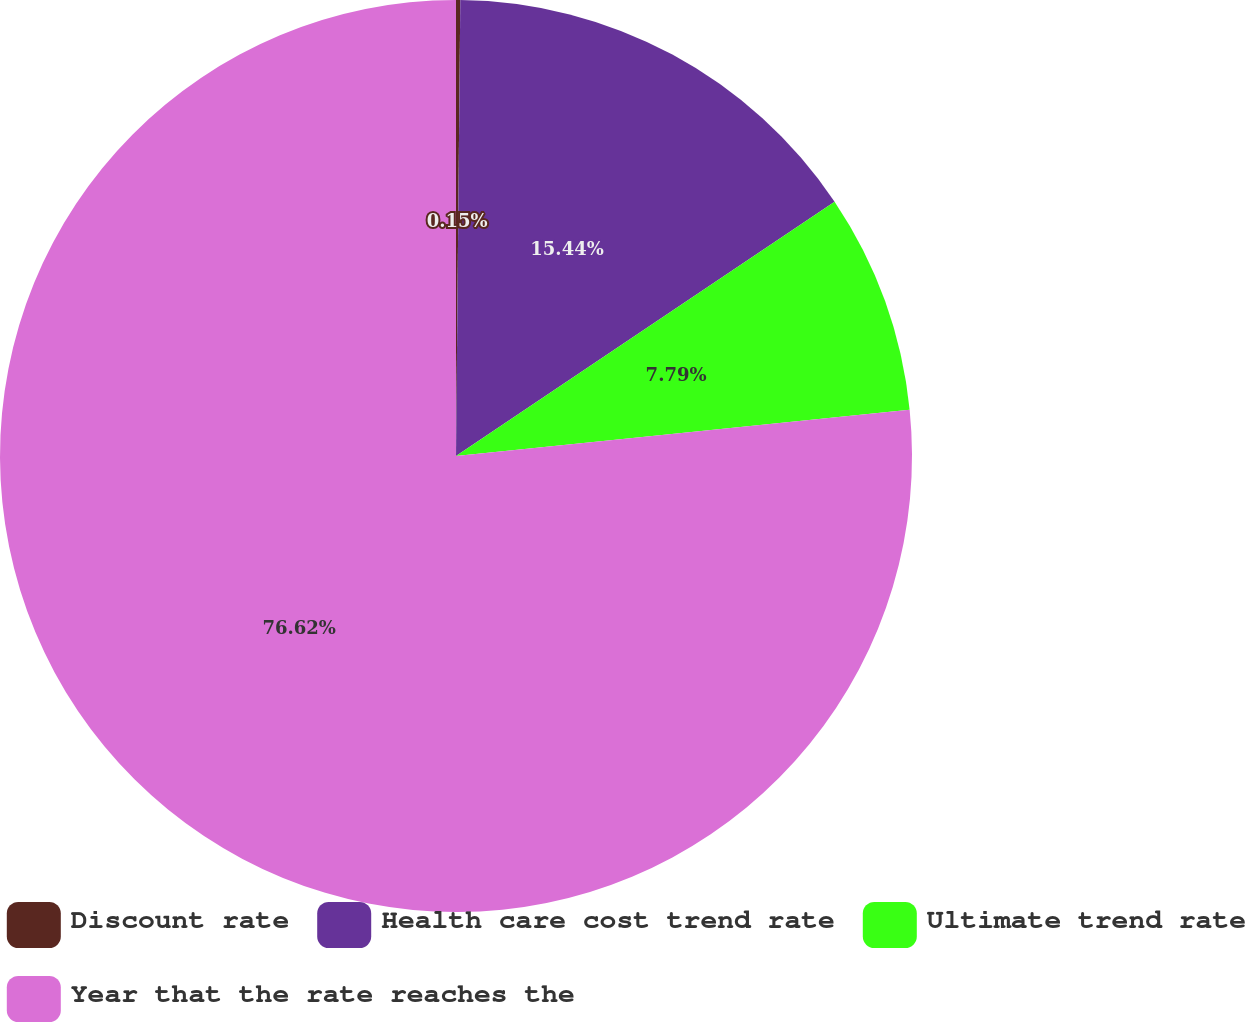Convert chart. <chart><loc_0><loc_0><loc_500><loc_500><pie_chart><fcel>Discount rate<fcel>Health care cost trend rate<fcel>Ultimate trend rate<fcel>Year that the rate reaches the<nl><fcel>0.15%<fcel>15.44%<fcel>7.79%<fcel>76.62%<nl></chart> 